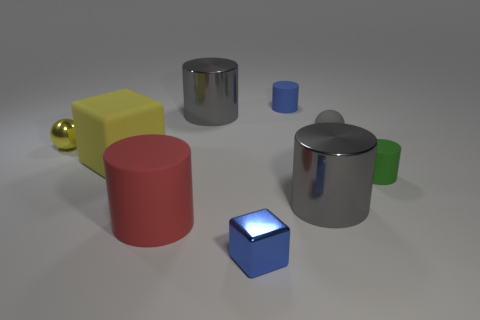Do the green thing and the small yellow thing have the same material?
Your answer should be compact. No. There is a metallic sphere behind the yellow matte object; how many tiny green matte things are on the right side of it?
Provide a succinct answer. 1. Are there any matte objects of the same shape as the yellow metal object?
Provide a succinct answer. Yes. There is a tiny blue thing in front of the large rubber cylinder; is it the same shape as the big metallic thing that is in front of the tiny green matte cylinder?
Make the answer very short. No. The thing that is behind the yellow sphere and to the left of the small blue cylinder has what shape?
Provide a short and direct response. Cylinder. Is there a green rubber block of the same size as the yellow ball?
Ensure brevity in your answer.  No. Does the metal cube have the same color as the rubber cylinder behind the big yellow matte object?
Provide a short and direct response. Yes. What is the material of the yellow cube?
Your answer should be very brief. Rubber. There is a big shiny cylinder left of the tiny blue matte cylinder; what color is it?
Give a very brief answer. Gray. How many metal things are the same color as the big matte cylinder?
Ensure brevity in your answer.  0. 